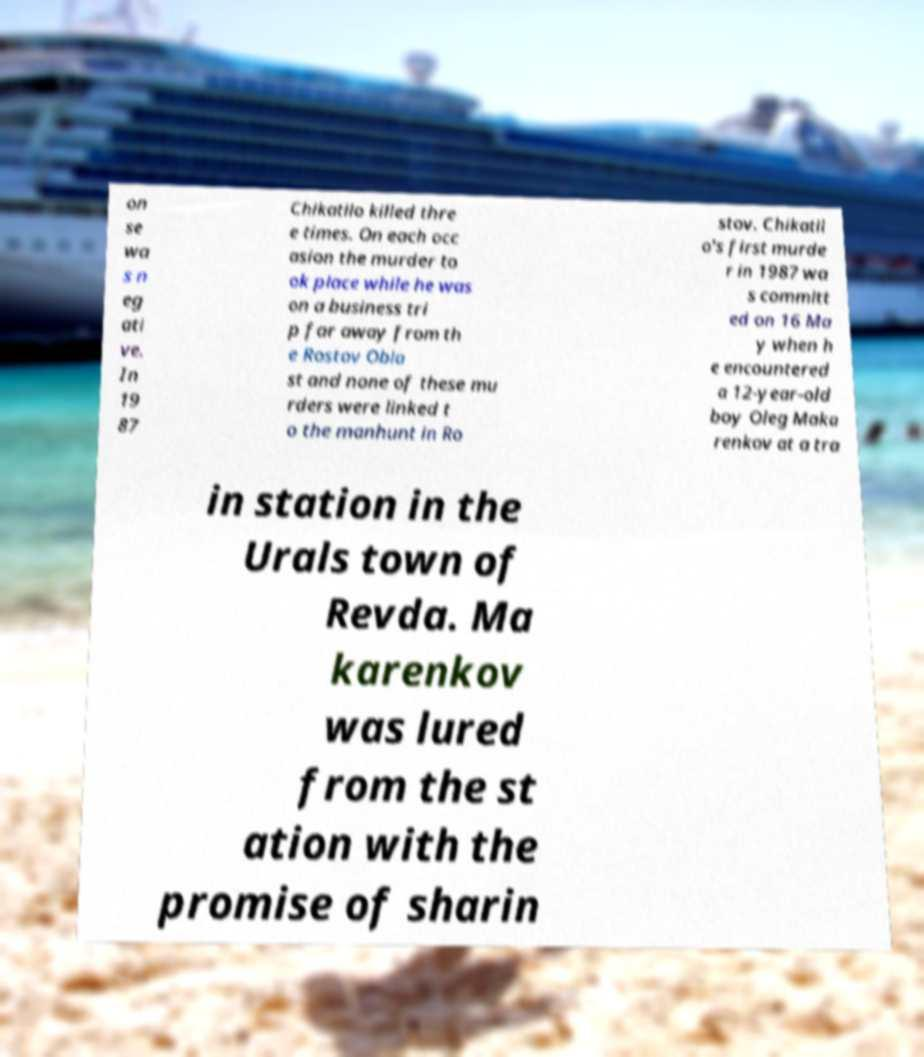Can you read and provide the text displayed in the image?This photo seems to have some interesting text. Can you extract and type it out for me? on se wa s n eg ati ve. In 19 87 Chikatilo killed thre e times. On each occ asion the murder to ok place while he was on a business tri p far away from th e Rostov Obla st and none of these mu rders were linked t o the manhunt in Ro stov. Chikatil o's first murde r in 1987 wa s committ ed on 16 Ma y when h e encountered a 12-year-old boy Oleg Maka renkov at a tra in station in the Urals town of Revda. Ma karenkov was lured from the st ation with the promise of sharin 